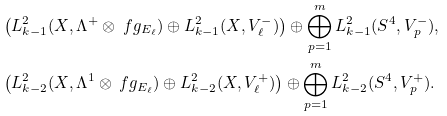Convert formula to latex. <formula><loc_0><loc_0><loc_500><loc_500>& \left ( L ^ { 2 } _ { k - 1 } ( X , \Lambda ^ { + } \otimes \ f g _ { E _ { \ell } } ) \oplus L ^ { 2 } _ { k - 1 } ( X , V _ { \ell } ^ { - } ) \right ) \oplus \bigoplus _ { p = 1 } ^ { m } L ^ { 2 } _ { k - 1 } ( S ^ { 4 } , V _ { p } ^ { - } ) , \\ & \left ( L ^ { 2 } _ { k - 2 } ( X , \Lambda ^ { 1 } \otimes \ f g _ { E _ { \ell } } ) \oplus L ^ { 2 } _ { k - 2 } ( X , V _ { \ell } ^ { + } ) \right ) \oplus \bigoplus _ { p = 1 } ^ { m } L ^ { 2 } _ { k - 2 } ( S ^ { 4 } , V _ { p } ^ { + } ) .</formula> 